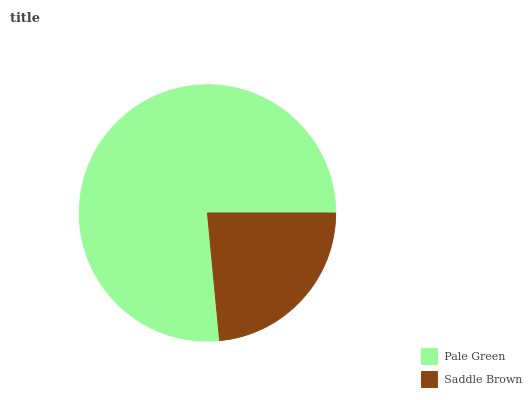Is Saddle Brown the minimum?
Answer yes or no. Yes. Is Pale Green the maximum?
Answer yes or no. Yes. Is Saddle Brown the maximum?
Answer yes or no. No. Is Pale Green greater than Saddle Brown?
Answer yes or no. Yes. Is Saddle Brown less than Pale Green?
Answer yes or no. Yes. Is Saddle Brown greater than Pale Green?
Answer yes or no. No. Is Pale Green less than Saddle Brown?
Answer yes or no. No. Is Pale Green the high median?
Answer yes or no. Yes. Is Saddle Brown the low median?
Answer yes or no. Yes. Is Saddle Brown the high median?
Answer yes or no. No. Is Pale Green the low median?
Answer yes or no. No. 